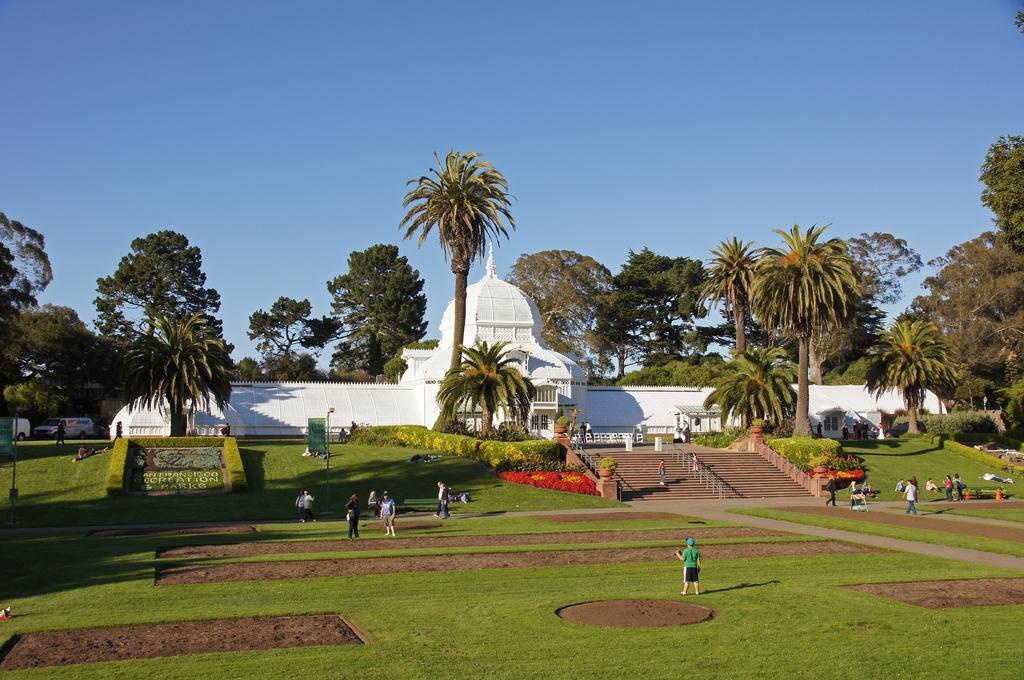What type of structure is visible in the image? There is a house in the image. What can be seen surrounding the house? There are trees around the house. What other types of vegetation are present in the image? There are plants in the image. Can you describe the people in the image? There are people in the image. What are the poles used for in the image? The purpose of the poles is not specified in the image. What type of ground cover is visible in the image? There is grass in the image. What type of straw is being used to make a comparison between the people in the image? There is no straw present in the image, nor is there any indication of a comparison being made between the people. 